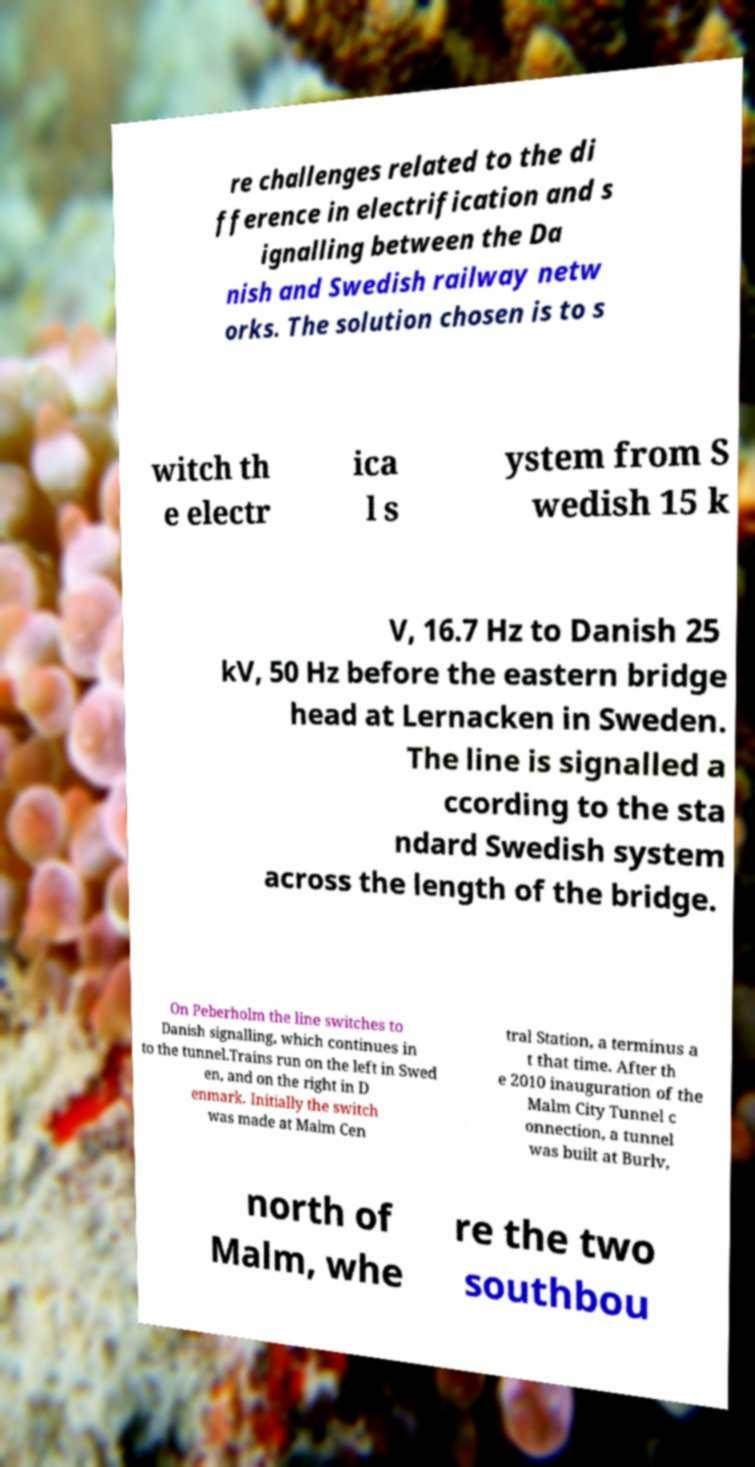Please identify and transcribe the text found in this image. re challenges related to the di fference in electrification and s ignalling between the Da nish and Swedish railway netw orks. The solution chosen is to s witch th e electr ica l s ystem from S wedish 15 k V, 16.7 Hz to Danish 25 kV, 50 Hz before the eastern bridge head at Lernacken in Sweden. The line is signalled a ccording to the sta ndard Swedish system across the length of the bridge. On Peberholm the line switches to Danish signalling, which continues in to the tunnel.Trains run on the left in Swed en, and on the right in D enmark. Initially the switch was made at Malm Cen tral Station, a terminus a t that time. After th e 2010 inauguration of the Malm City Tunnel c onnection, a tunnel was built at Burlv, north of Malm, whe re the two southbou 